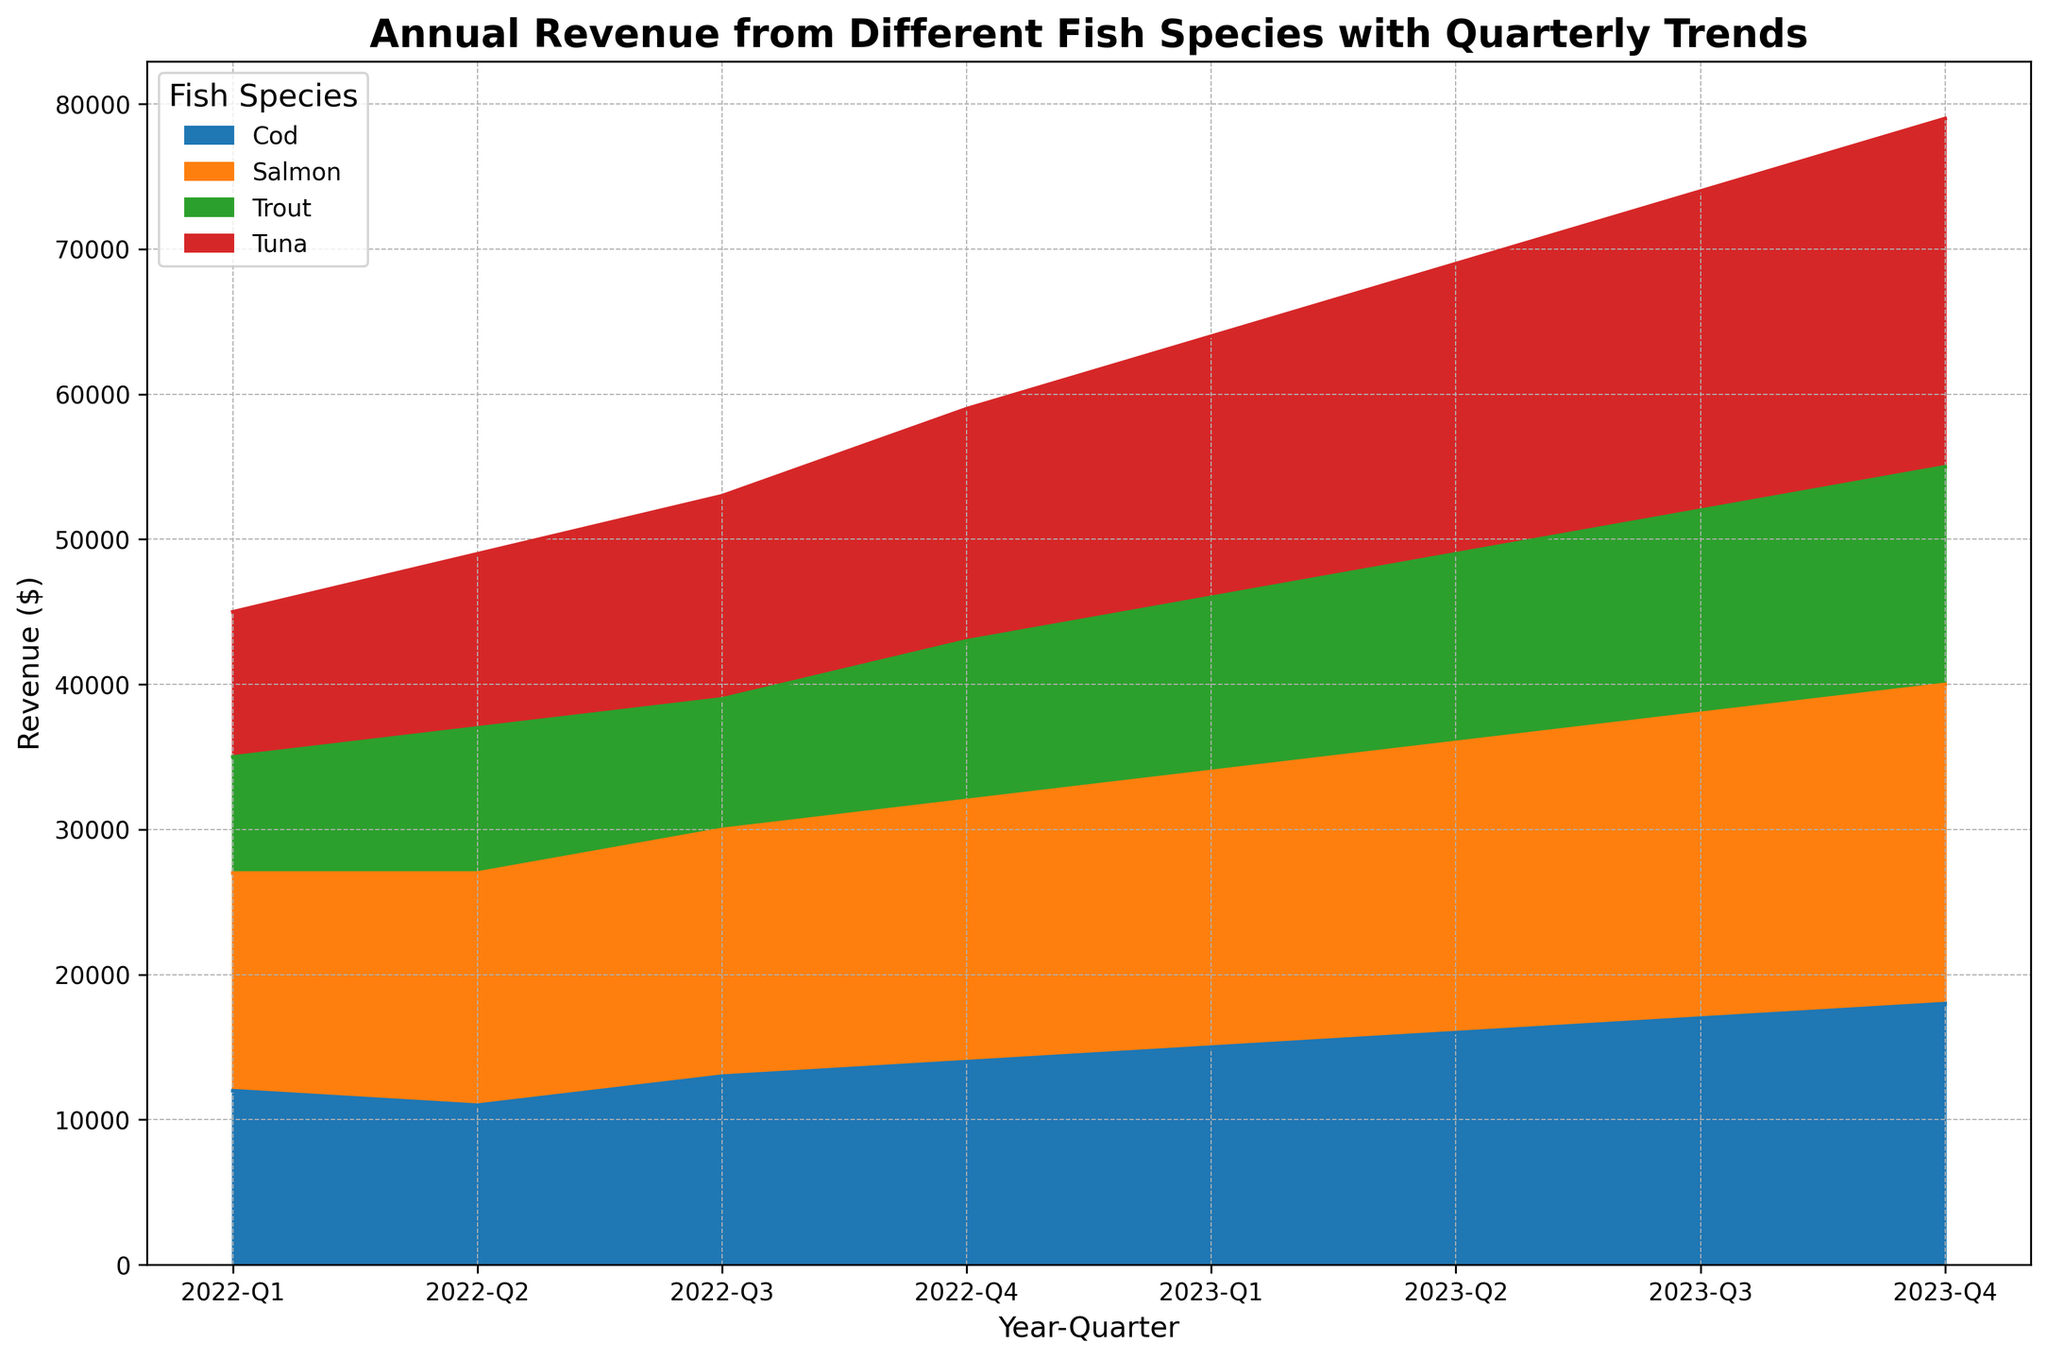What is the revenue for Salmon in Q4 of 2023? First, locate the part of the graph where Q4 2023 is depicted, and then look at the corresponding section for Salmon within that quarter. The topmost layer for that segment will represent Salmon's revenue.
Answer: 22000 Which fish species had the highest revenue in Q1 of 2022? Identify Q1 of 2022 on the x-axis, then look at the stacked layers corresponding to each species. The species forming the topmost layer will have the highest revenue; in this case, it's Salmon.
Answer: Salmon Compare the revenue of Tuna and Cod in Q3 of 2023. Which one is higher and by how much? Locate Q3 2023 on the x-axis, then find the heights of the respective areas for Tuna and Cod. Tuna's area is higher. Subtract Cod's revenue (17000) from Tuna's revenue (22000) to find the difference.
Answer: Tuna by 5000 What is the total revenue for all species in Q2 of 2023? Determine the height of the stacked area for Q2 of 2023, which represents the sum of all revenues. Sum up the revenues for each species for that quarter: Tuna (20000) + Salmon (20000) + Trout (13000) + Cod (16000).
Answer: 69000 Has the revenue for Trout shown a constant increase from Q1 2022 to Q4 2023? Observe the trend for Trout from Q1 2022 to Q4 2023. While Trout’s revenue generally increases, it shows minor fluctuations: 8000 in Q1 2022, 10000 in Q2 2022, 9000 in Q3 2022, and so on.
Answer: No What's the combined revenue of Salmon and Cod for Q4 of 2022? Locate Q4 2022 on the x-axis and add the revenues for Salmon (18000) and Cod (14000).
Answer: 32000 Which species has the largest increase in revenue from Q4 2022 to Q4 2023? To find the species with the largest increase, compare individual revenues from Q4 2022 to Q4 2023 for each species. Calculate the differences and see that Tuna increased from 16000 to 24000 (an increase of 8000).
Answer: Tuna During which quarter of 2022 did Cod have its lowest revenue? Examine each quarter of 2022 for Cod. Identify the lowest stack portion for Cod, which is Q2 with 11000.
Answer: Q2 In which year and quarter did Trout achieve the highest revenue? Inspect the entire timeframe for the highest point in Trout's area. This occurs in Q4 2023 with a revenue of 15000.
Answer: Q4 2023 Compare the total revenue trend of Salmon from 2022 to 2023. Visualize the area covered by Salmon's color segment from 2022 to 2023, noting its consistent upward progression and higher revenues every quarter.
Answer: Increasing 